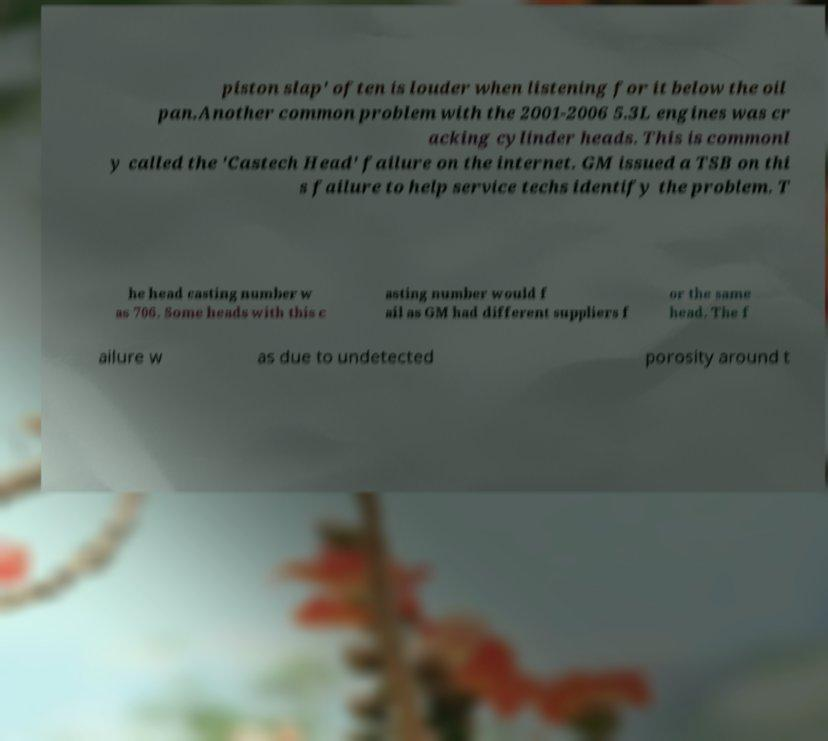Can you read and provide the text displayed in the image?This photo seems to have some interesting text. Can you extract and type it out for me? piston slap' often is louder when listening for it below the oil pan.Another common problem with the 2001-2006 5.3L engines was cr acking cylinder heads. This is commonl y called the 'Castech Head' failure on the internet. GM issued a TSB on thi s failure to help service techs identify the problem. T he head casting number w as 706. Some heads with this c asting number would f ail as GM had different suppliers f or the same head. The f ailure w as due to undetected porosity around t 